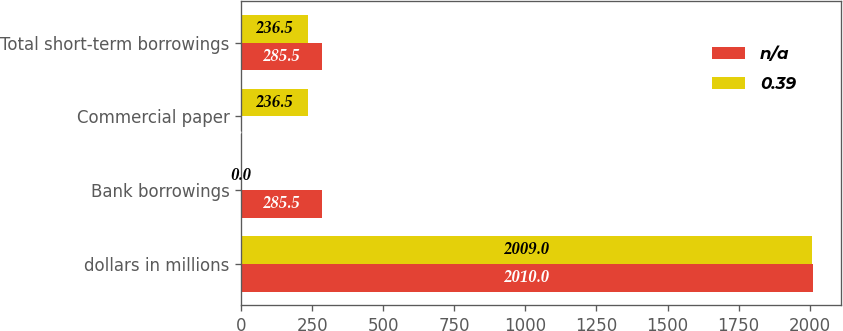Convert chart to OTSL. <chart><loc_0><loc_0><loc_500><loc_500><stacked_bar_chart><ecel><fcel>dollars in millions<fcel>Bank borrowings<fcel>Commercial paper<fcel>Total short-term borrowings<nl><fcel>nan<fcel>2010<fcel>285.5<fcel>0<fcel>285.5<nl><fcel>0.39<fcel>2009<fcel>0<fcel>236.5<fcel>236.5<nl></chart> 